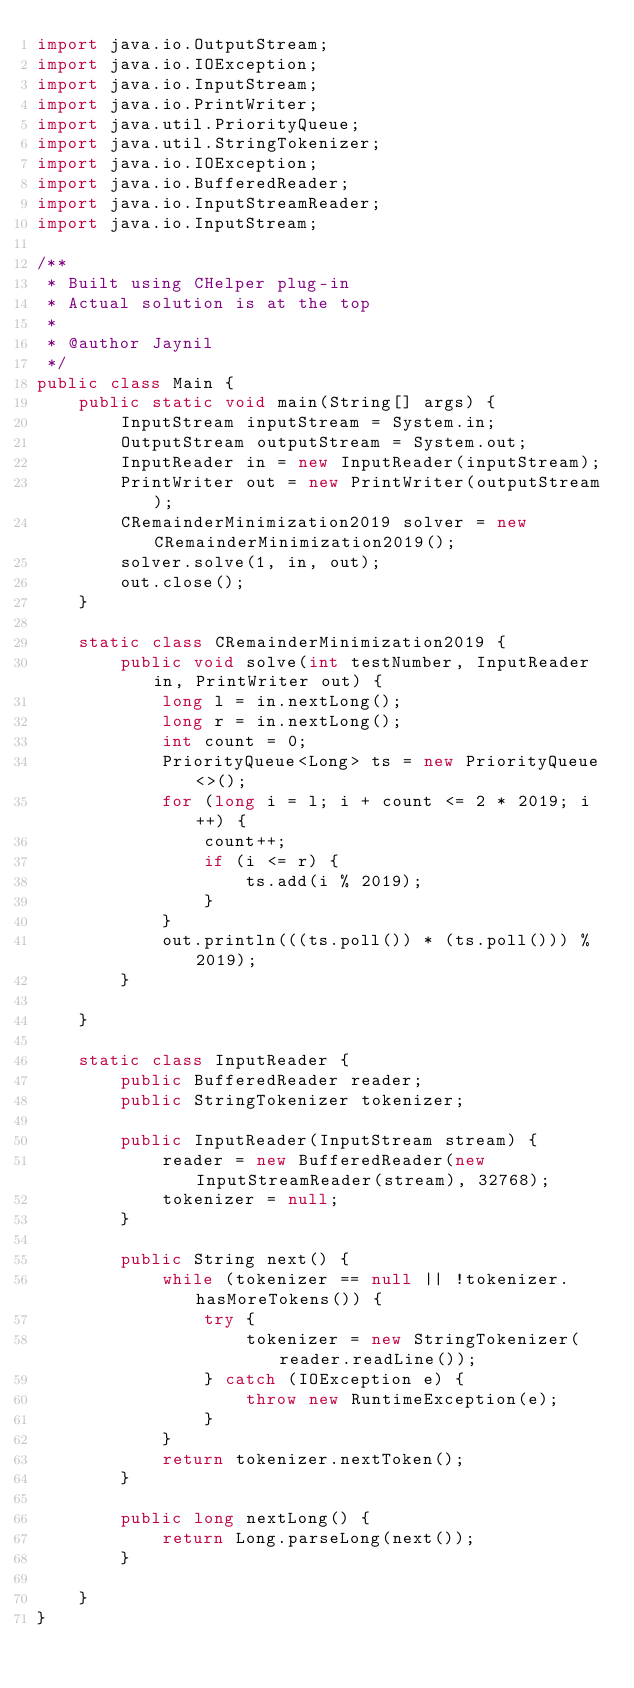Convert code to text. <code><loc_0><loc_0><loc_500><loc_500><_Java_>import java.io.OutputStream;
import java.io.IOException;
import java.io.InputStream;
import java.io.PrintWriter;
import java.util.PriorityQueue;
import java.util.StringTokenizer;
import java.io.IOException;
import java.io.BufferedReader;
import java.io.InputStreamReader;
import java.io.InputStream;

/**
 * Built using CHelper plug-in
 * Actual solution is at the top
 *
 * @author Jaynil
 */
public class Main {
    public static void main(String[] args) {
        InputStream inputStream = System.in;
        OutputStream outputStream = System.out;
        InputReader in = new InputReader(inputStream);
        PrintWriter out = new PrintWriter(outputStream);
        CRemainderMinimization2019 solver = new CRemainderMinimization2019();
        solver.solve(1, in, out);
        out.close();
    }

    static class CRemainderMinimization2019 {
        public void solve(int testNumber, InputReader in, PrintWriter out) {
            long l = in.nextLong();
            long r = in.nextLong();
            int count = 0;
            PriorityQueue<Long> ts = new PriorityQueue<>();
            for (long i = l; i + count <= 2 * 2019; i++) {
                count++;
                if (i <= r) {
                    ts.add(i % 2019);
                }
            }
            out.println(((ts.poll()) * (ts.poll())) % 2019);
        }

    }

    static class InputReader {
        public BufferedReader reader;
        public StringTokenizer tokenizer;

        public InputReader(InputStream stream) {
            reader = new BufferedReader(new InputStreamReader(stream), 32768);
            tokenizer = null;
        }

        public String next() {
            while (tokenizer == null || !tokenizer.hasMoreTokens()) {
                try {
                    tokenizer = new StringTokenizer(reader.readLine());
                } catch (IOException e) {
                    throw new RuntimeException(e);
                }
            }
            return tokenizer.nextToken();
        }

        public long nextLong() {
            return Long.parseLong(next());
        }

    }
}

</code> 